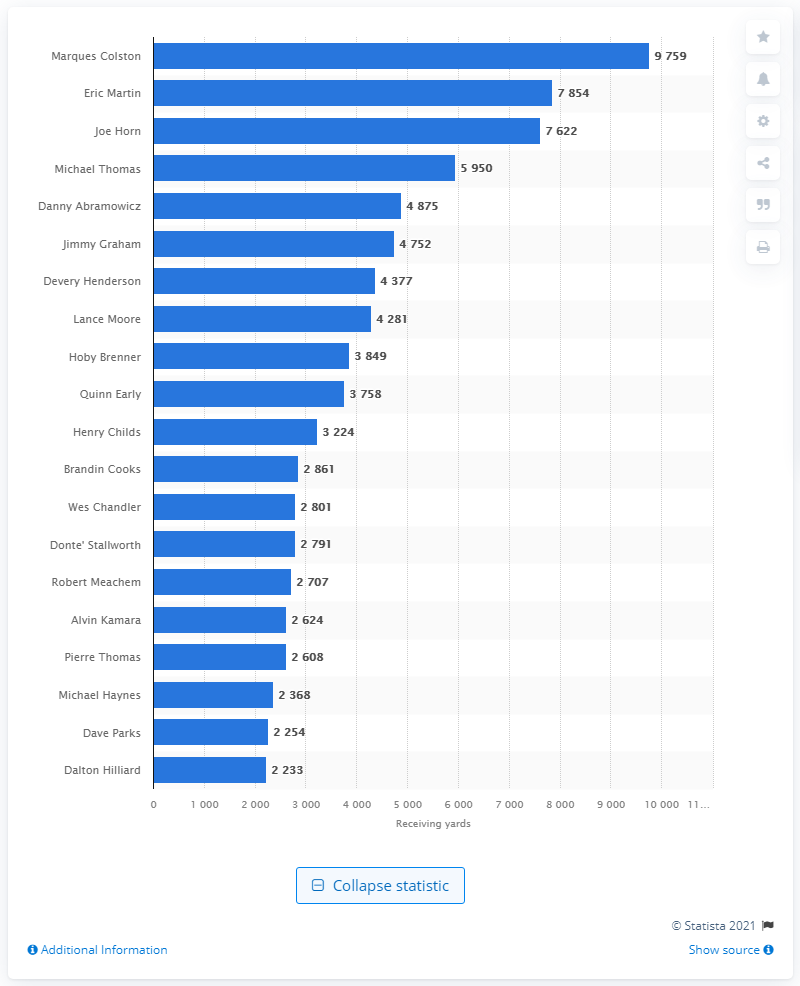Give some essential details in this illustration. Marques Colston is the career receiving leader of the New Orleans Saints. 